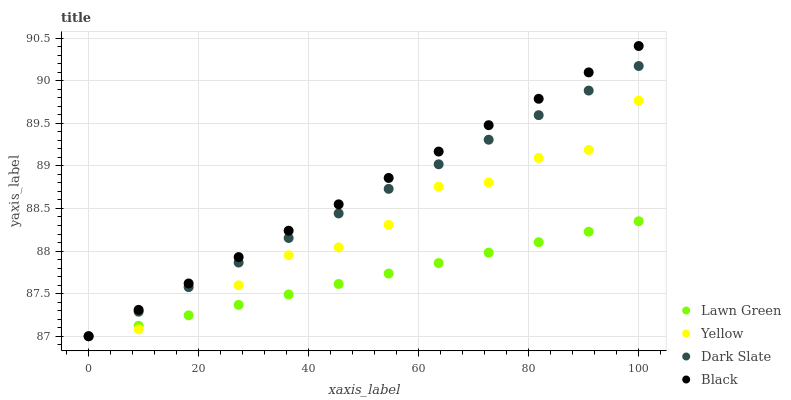Does Lawn Green have the minimum area under the curve?
Answer yes or no. Yes. Does Black have the maximum area under the curve?
Answer yes or no. Yes. Does Yellow have the minimum area under the curve?
Answer yes or no. No. Does Yellow have the maximum area under the curve?
Answer yes or no. No. Is Black the smoothest?
Answer yes or no. Yes. Is Yellow the roughest?
Answer yes or no. Yes. Is Yellow the smoothest?
Answer yes or no. No. Is Black the roughest?
Answer yes or no. No. Does Lawn Green have the lowest value?
Answer yes or no. Yes. Does Black have the highest value?
Answer yes or no. Yes. Does Yellow have the highest value?
Answer yes or no. No. Does Lawn Green intersect Yellow?
Answer yes or no. Yes. Is Lawn Green less than Yellow?
Answer yes or no. No. Is Lawn Green greater than Yellow?
Answer yes or no. No. 